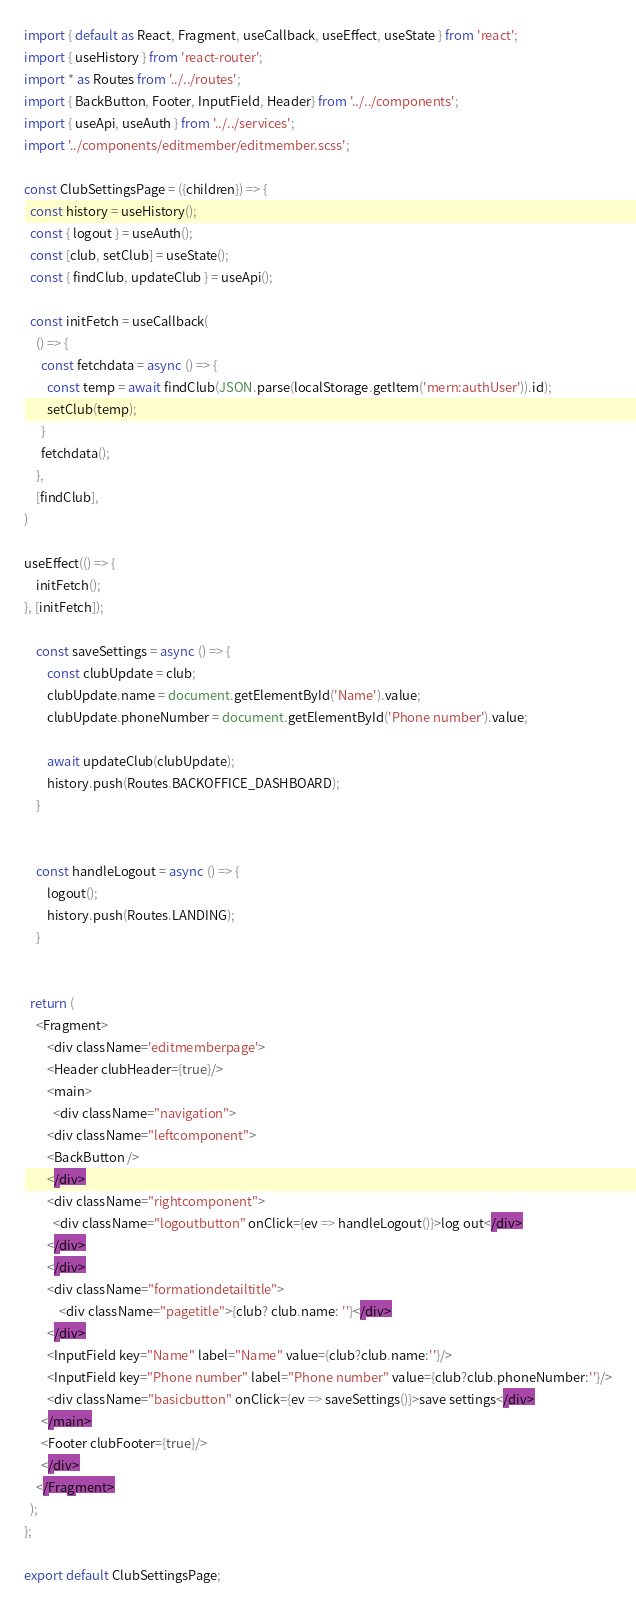Convert code to text. <code><loc_0><loc_0><loc_500><loc_500><_JavaScript_>import { default as React, Fragment, useCallback, useEffect, useState } from 'react';
import { useHistory } from 'react-router';
import * as Routes from '../../routes';
import { BackButton, Footer, InputField, Header} from '../../components';
import { useApi, useAuth } from '../../services';
import '../components/editmember/editmember.scss';

const ClubSettingsPage = ({children}) => {
  const history = useHistory();
  const { logout } = useAuth();
  const [club, setClub] = useState();
  const { findClub, updateClub } = useApi();

  const initFetch = useCallback(
	() => {
	  const fetchdata = async () => {
		const temp = await findClub(JSON.parse(localStorage.getItem('mern:authUser')).id);
		setClub(temp);
	  }
	  fetchdata();
	},
	[findClub],
)

useEffect(() => {
	initFetch();
}, [initFetch]);

	const saveSettings = async () => {
		const clubUpdate = club;
		clubUpdate.name = document.getElementById('Name').value;
		clubUpdate.phoneNumber = document.getElementById('Phone number').value;

		await updateClub(clubUpdate);
		history.push(Routes.BACKOFFICE_DASHBOARD);
	}

	  
	const handleLogout = async () => {
		logout();
		history.push(Routes.LANDING);
	}


  return (
    <Fragment>
		<div className='editmemberpage'>
		<Header clubHeader={true}/>
      	<main>
		  <div className="navigation">
        <div className="leftcomponent">
		<BackButton />
        </div>
        <div className="rightcomponent">
          <div className="logoutbutton" onClick={ev => handleLogout()}>log out</div>
        </div>
        </div>
		<div className="formationdetailtitle">
			<div className="pagetitle">{club? club.name: ''}</div>
		</div>
		<InputField key="Name" label="Name" value={club?club.name:''}/>
		<InputField key="Phone number" label="Phone number" value={club?club.phoneNumber:''}/>
		<div className="basicbutton" onClick={ev => saveSettings()}>save settings</div>
      </main>
      <Footer clubFooter={true}/>
	  </div>
    </Fragment>
  );
};

export default ClubSettingsPage;</code> 